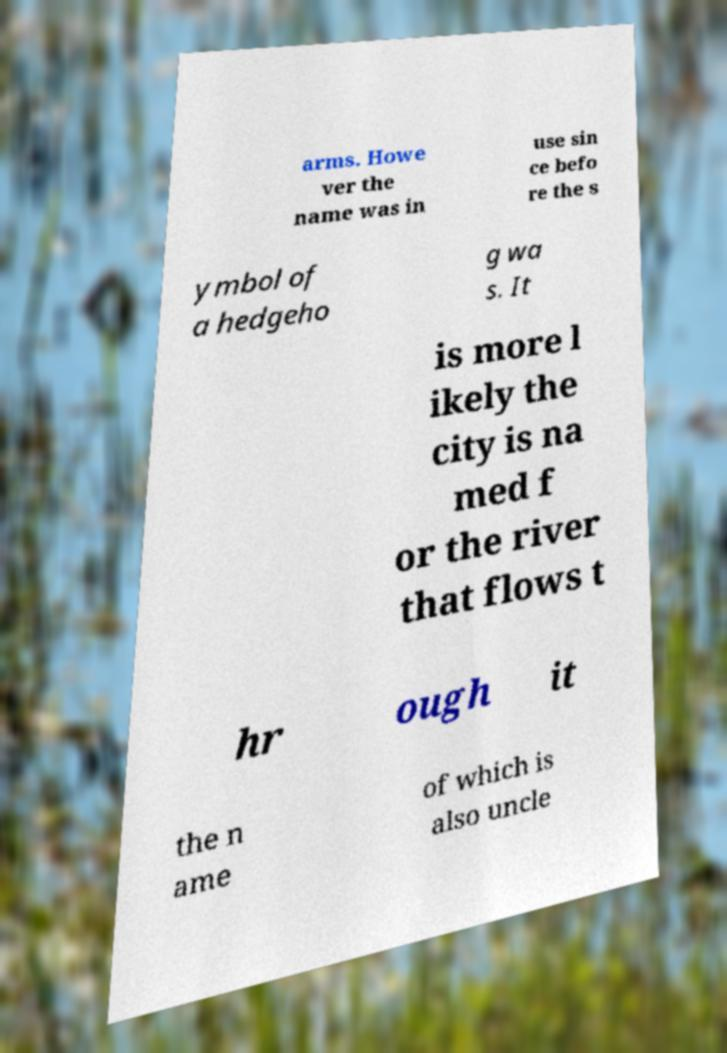For documentation purposes, I need the text within this image transcribed. Could you provide that? arms. Howe ver the name was in use sin ce befo re the s ymbol of a hedgeho g wa s. It is more l ikely the city is na med f or the river that flows t hr ough it the n ame of which is also uncle 